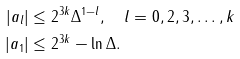<formula> <loc_0><loc_0><loc_500><loc_500>| a _ { l } | & \leq 2 ^ { 3 k } \Delta ^ { 1 - l } , \quad l = 0 , 2 , 3 , \dots , k \\ | a _ { 1 } | & \leq 2 ^ { 3 k } - \ln \Delta .</formula> 